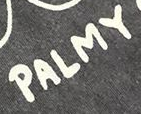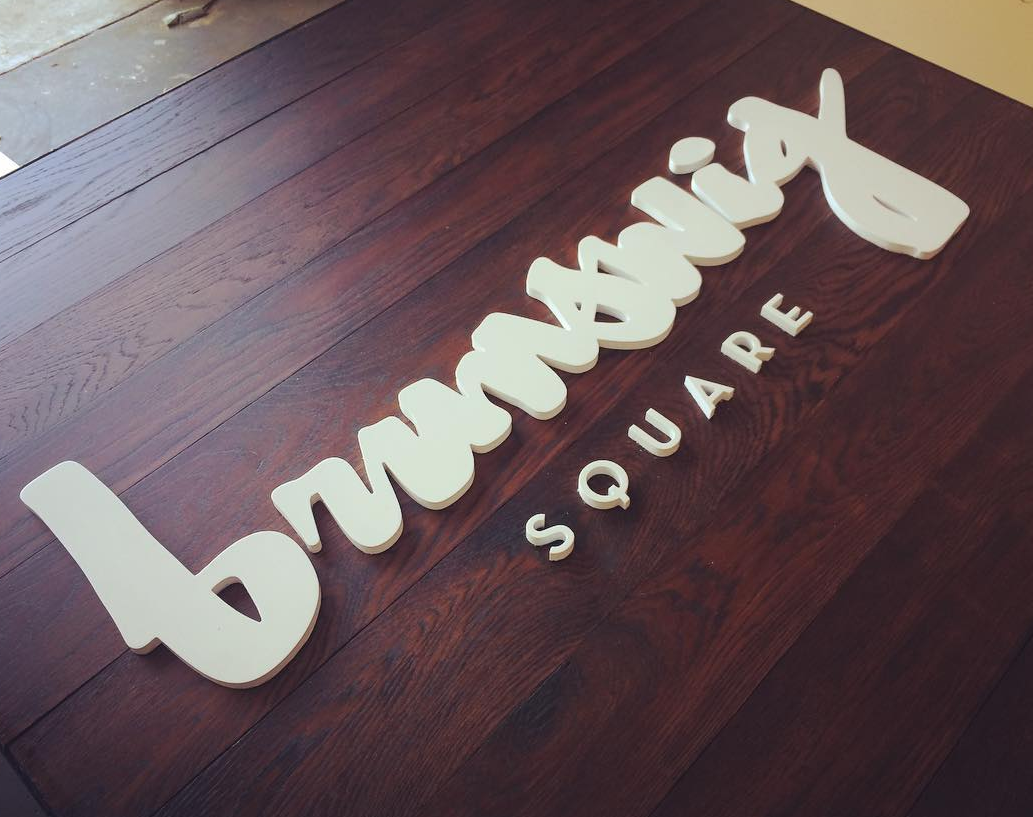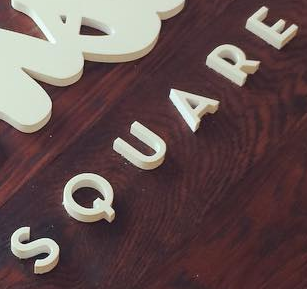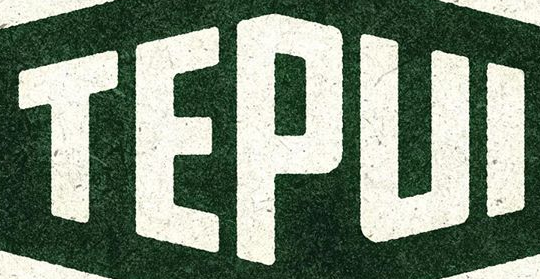Transcribe the words shown in these images in order, separated by a semicolon. PALMY; brunswig; SQUARE; TEPUI 